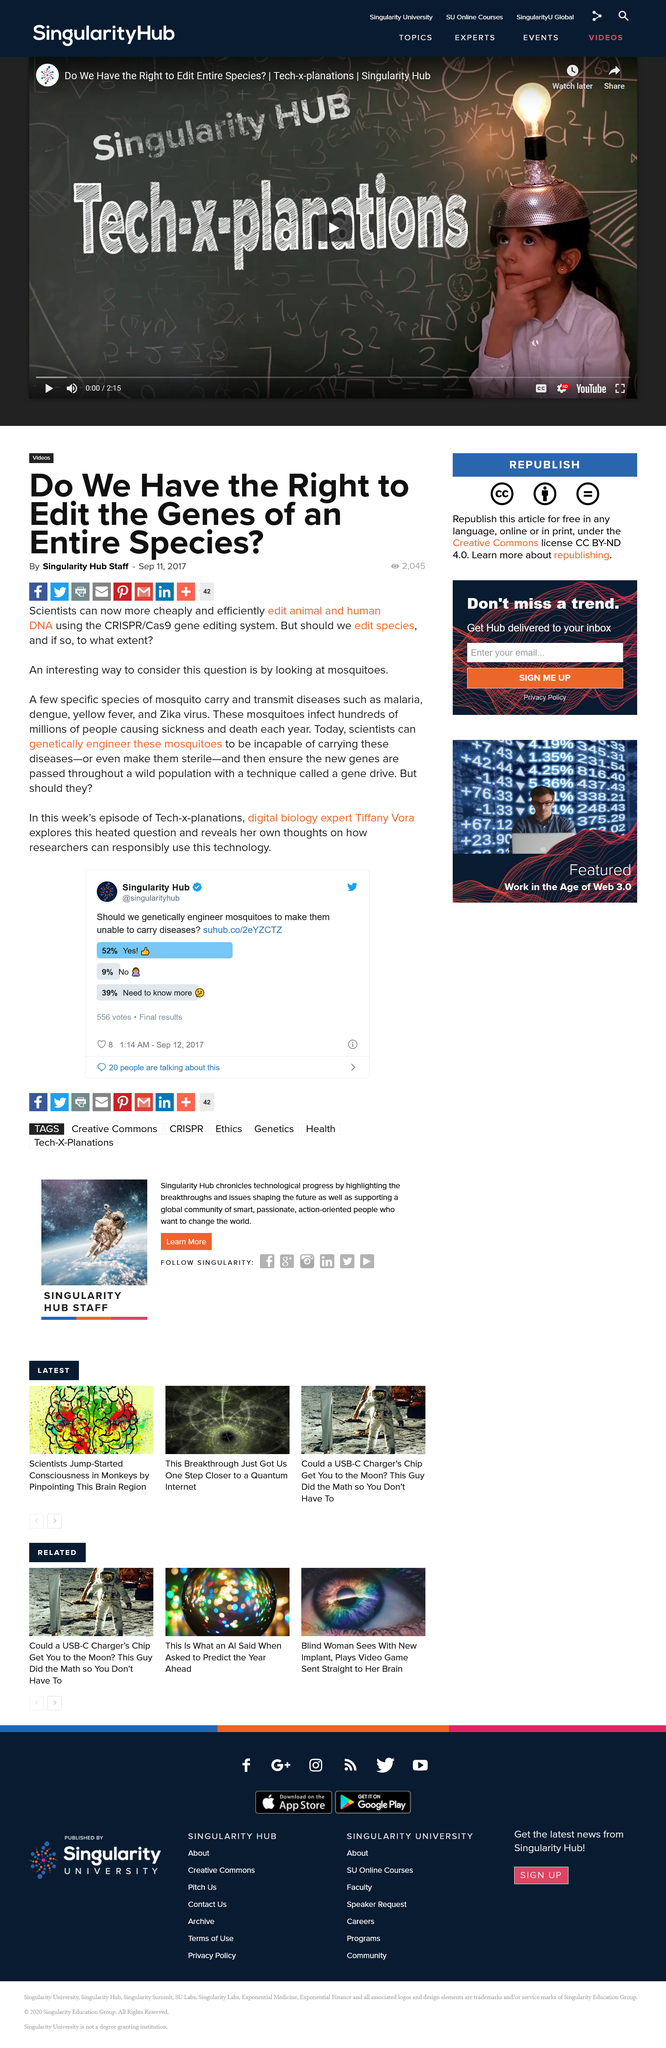Identify some key points in this picture. Scientists have the ability to utilize the CRISPR/Cas9 gene editing system to manipulate the genetic makeup of mosquitos, making it possible to render them incapable of carrying disease or to render them sterile. The article was created by the Singularity Hub Staff. Mosquitoes are known to transmit various diseases to humans and animals, including malaria, dengue fever, yellow fever, and Zika virus. 